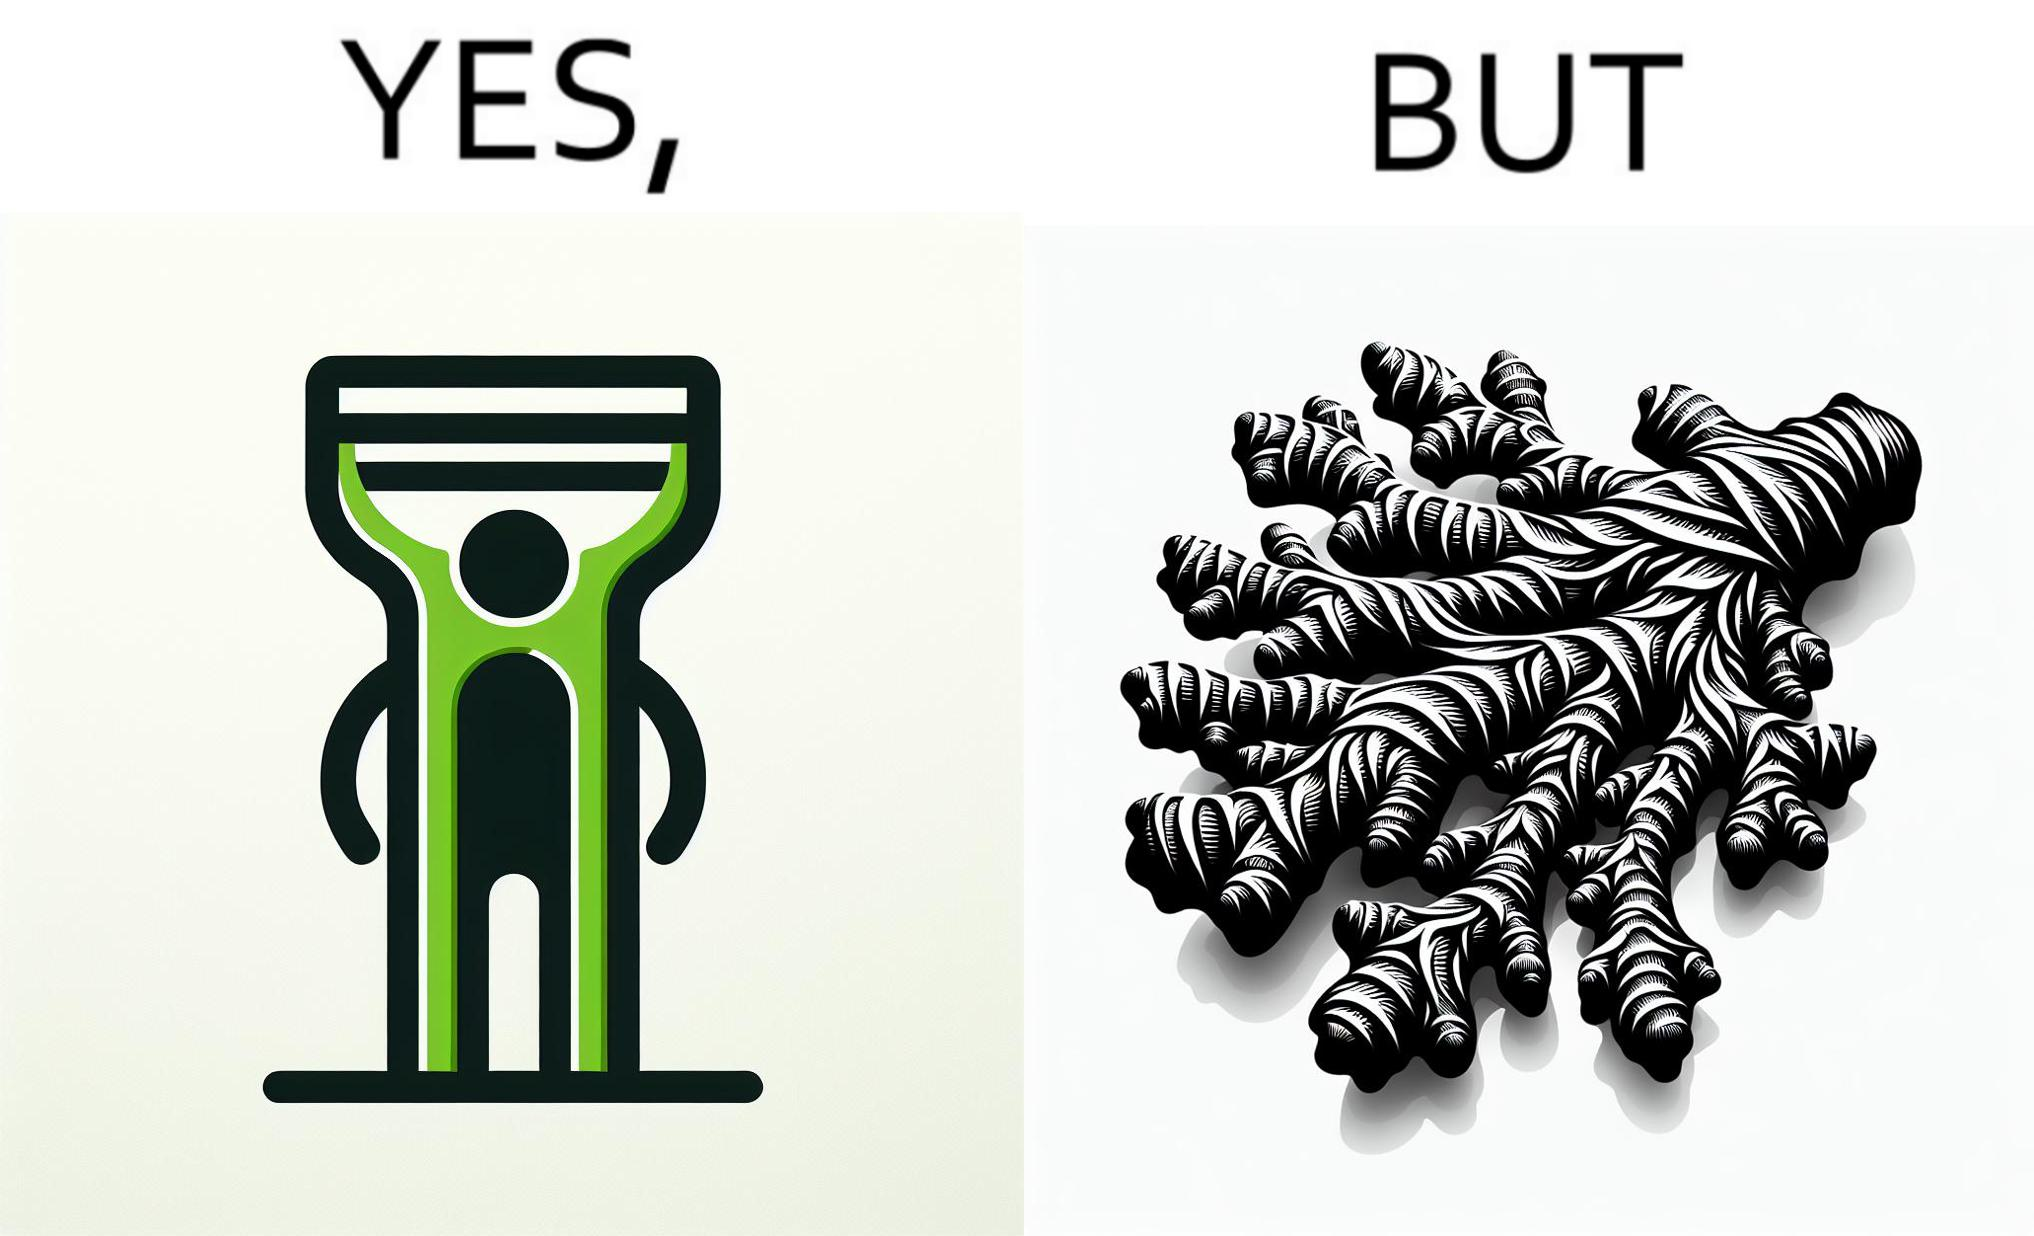Explain the humor or irony in this image. The image is funny because it suggests that while we have peelers to peel off the skin of many different fruits and vegetables, it is useless against a ginger which has a very complicated shape. 